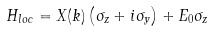<formula> <loc_0><loc_0><loc_500><loc_500>H _ { l o c } = X ( k ) \left ( \sigma _ { z } + i \sigma _ { y } \right ) + E _ { 0 } \sigma _ { z }</formula> 